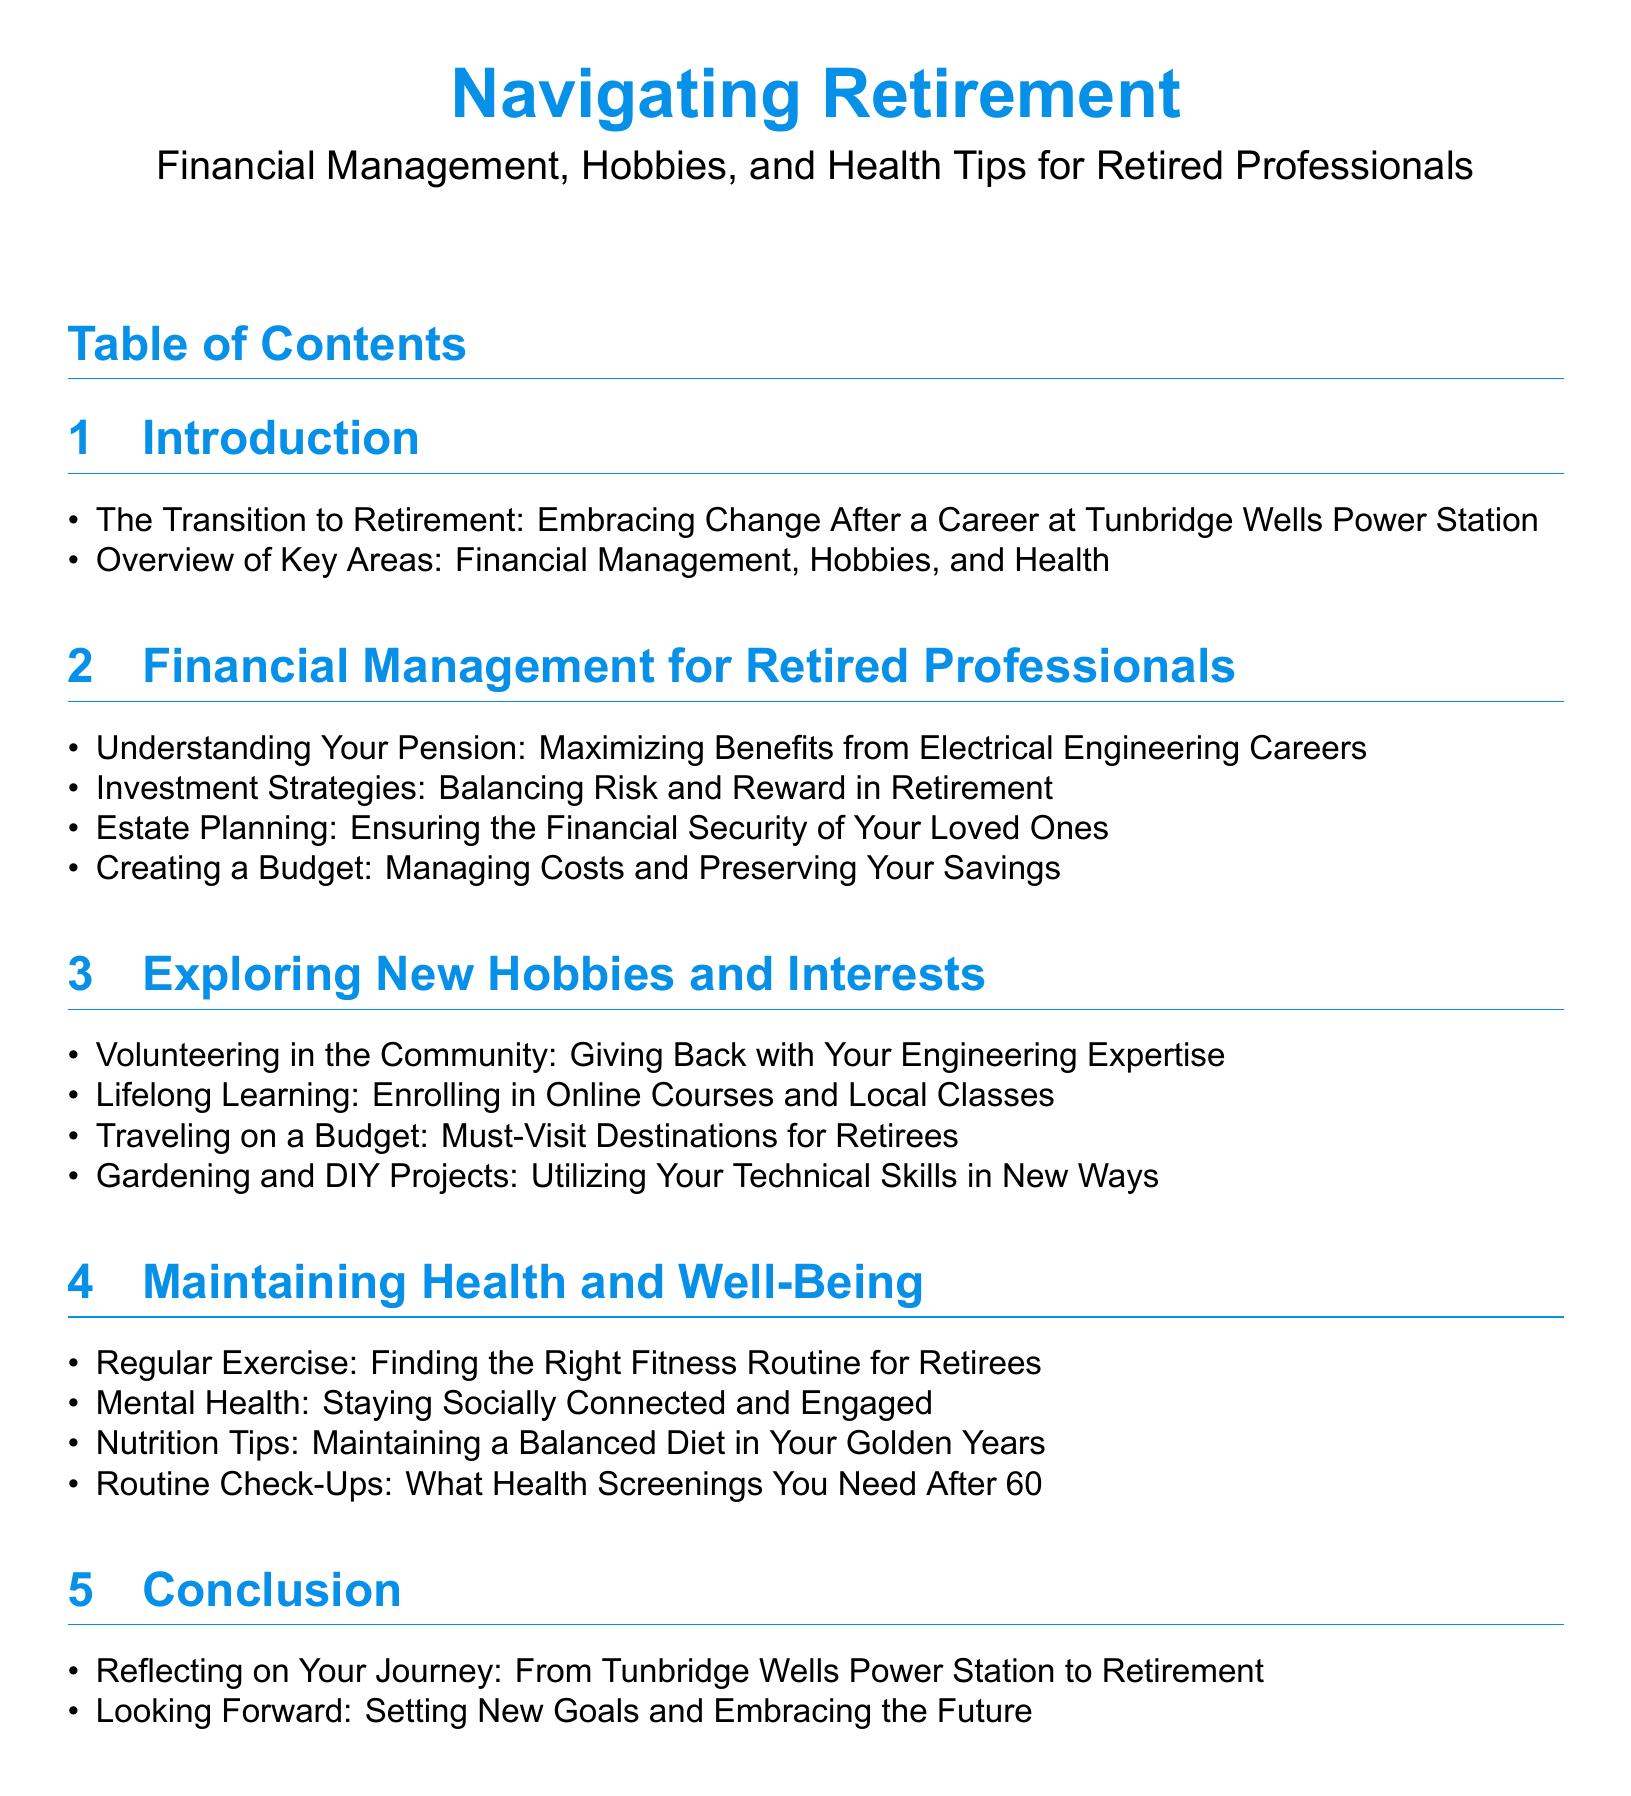what is the title of the document? The title of the document is prominently displayed at the beginning, indicating the main theme.
Answer: Navigating Retirement which section discusses financial management? This question asks for the specific section that covers financial management topics.
Answer: Financial Management for Retired Professionals how many items are listed under exploring new hobbies and interests? The number of items listed provides insight into the scope of activities suggested in the section.
Answer: 4 what is one of the topics covered under maintaining health and well-being? This question seeks a specific topic included in the health-related section of the document.
Answer: Regular Exercise what is the final section of the document? This asks for the concluding section that summarizes the document's content.
Answer: Conclusion how does the document suggest retirees give back to the community? The question requires integration of information about community contributions from the hobbies section.
Answer: Volunteering in the Community what topic is focused on ensuring financial security for loved ones? This question identifies a specific financial management strategy mentioned in the document.
Answer: Estate Planning what is mentioned as necessary after the age of 60? This question refers to health-related recommendations given in the document.
Answer: Routine Check-Ups 